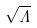Convert formula to latex. <formula><loc_0><loc_0><loc_500><loc_500>\sqrt { \Lambda }</formula> 